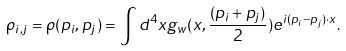<formula> <loc_0><loc_0><loc_500><loc_500>\rho _ { i , j } = \rho ( p _ { i } , p _ { j } ) = \int d ^ { 4 } x g _ { w } ( x , \frac { ( p _ { i } + p _ { j } ) } { 2 } ) e ^ { i ( p _ { i } - p _ { j } ) \cdot x } .</formula> 